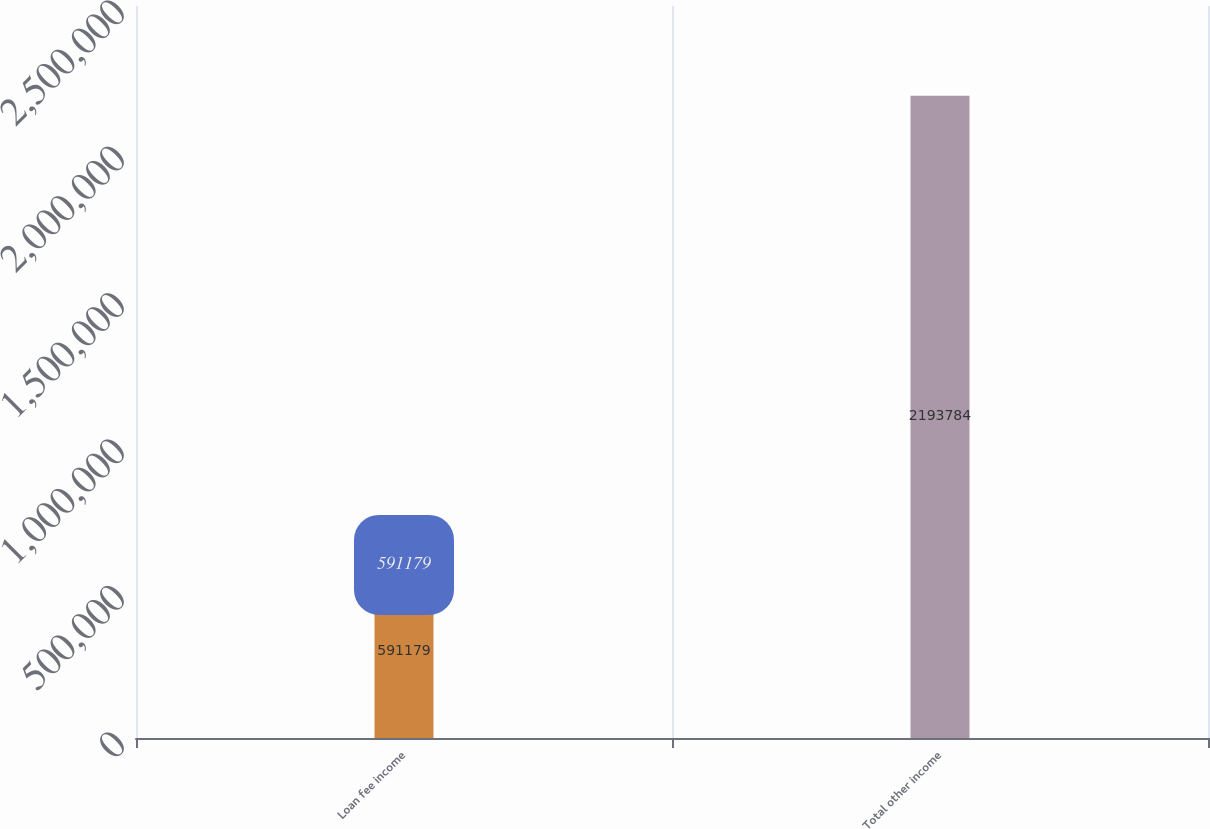Convert chart. <chart><loc_0><loc_0><loc_500><loc_500><bar_chart><fcel>Loan fee income<fcel>Total other income<nl><fcel>591179<fcel>2.19378e+06<nl></chart> 